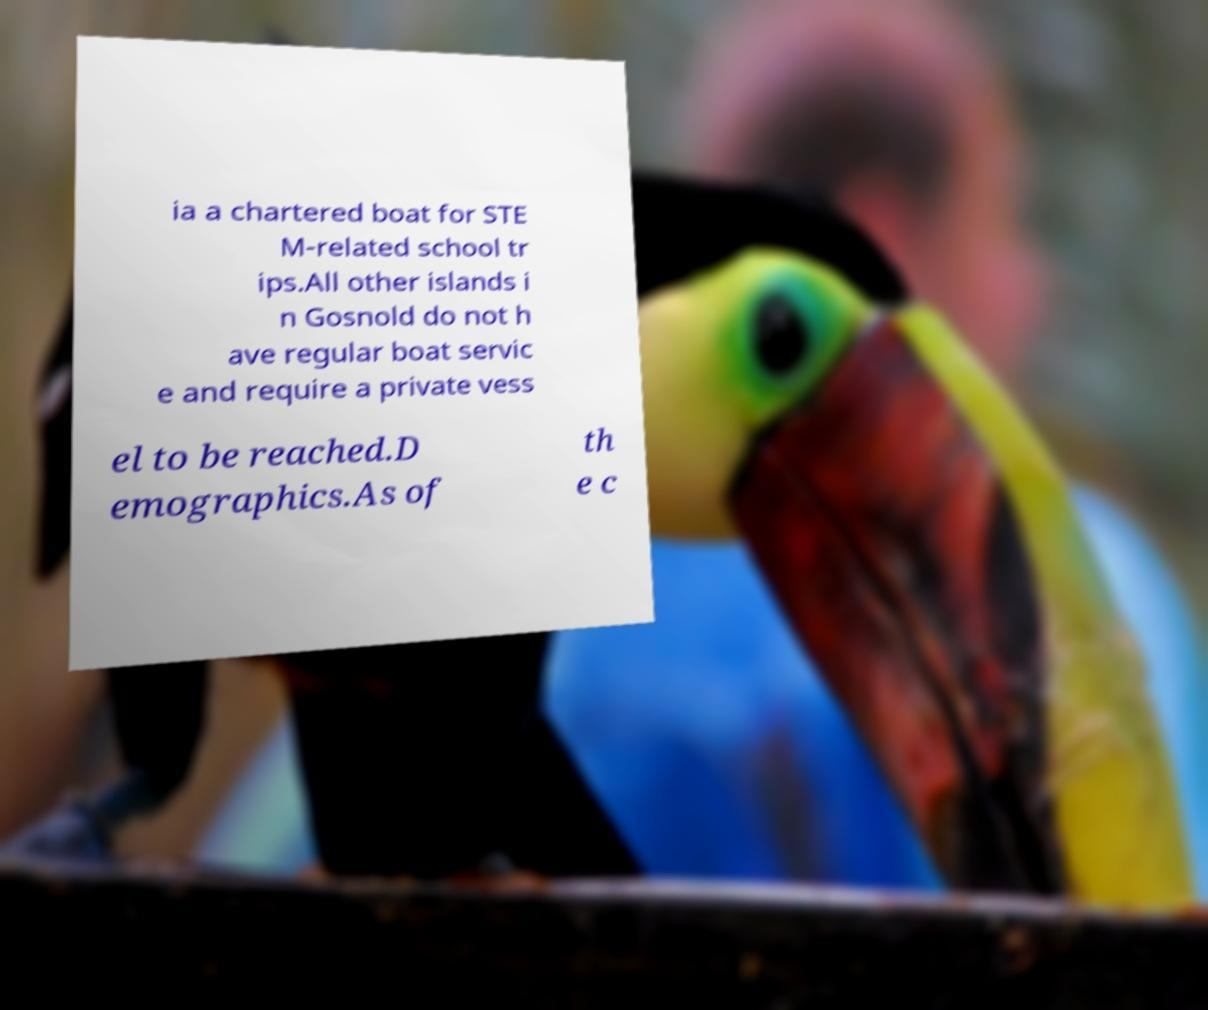Can you read and provide the text displayed in the image?This photo seems to have some interesting text. Can you extract and type it out for me? ia a chartered boat for STE M-related school tr ips.All other islands i n Gosnold do not h ave regular boat servic e and require a private vess el to be reached.D emographics.As of th e c 